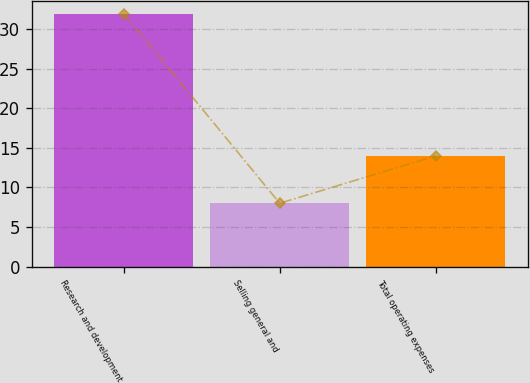Convert chart. <chart><loc_0><loc_0><loc_500><loc_500><bar_chart><fcel>Research and development<fcel>Selling general and<fcel>Total operating expenses<nl><fcel>32<fcel>8<fcel>14<nl></chart> 